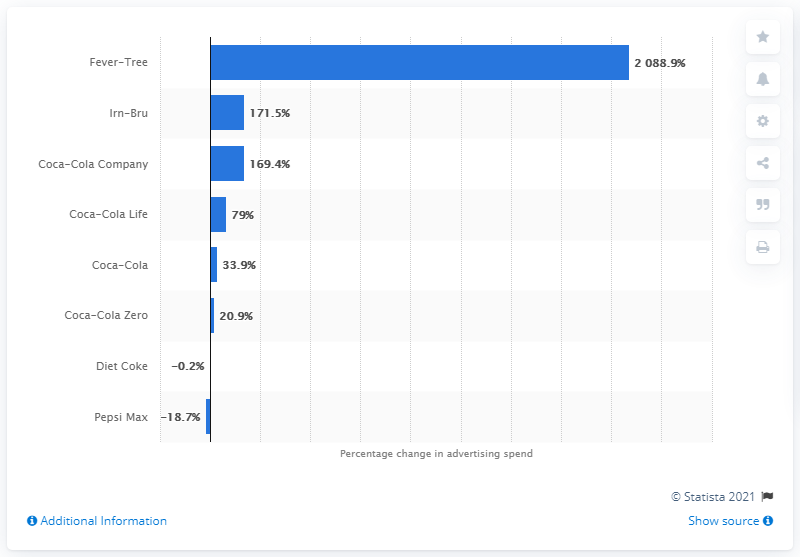List a handful of essential elements in this visual. Fever-Tree experienced the largest increase in advertising spending among all brands. 